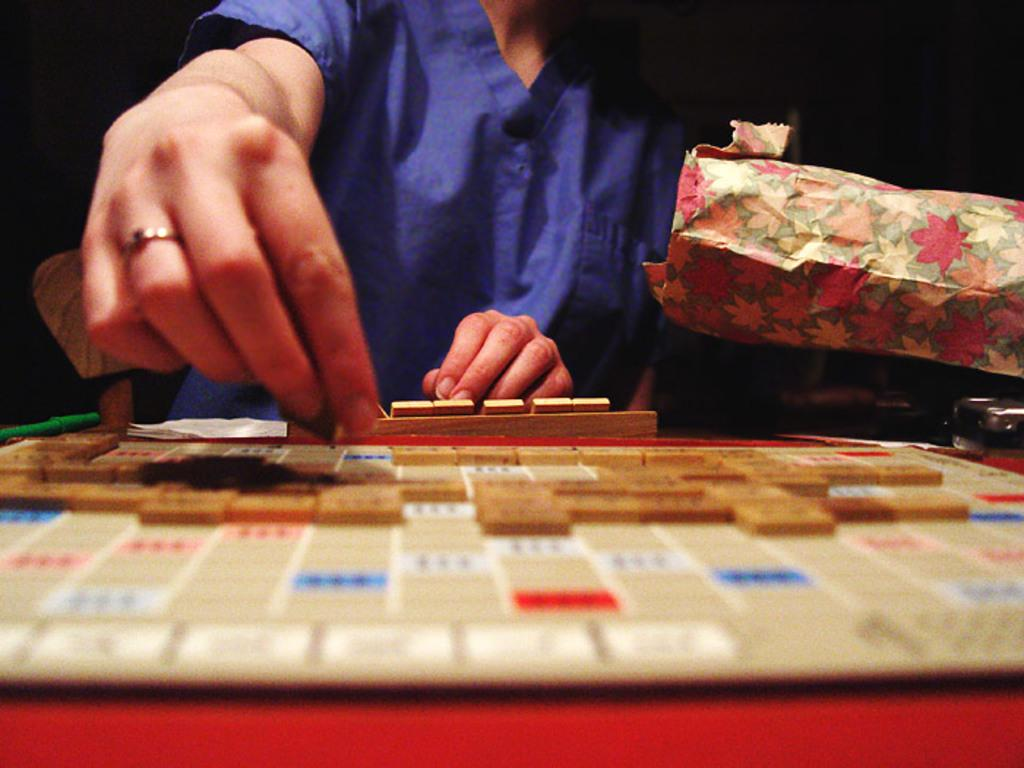What is the main object in the image? There is a word building board in the image. Where is the word building board located? The word building board is on a table. Who is present in the image? There is a person standing in the image. What is the person holding? The person is holding a grid. What time does the army arrive in the image? There is no mention of an army or any specific time in the image. 